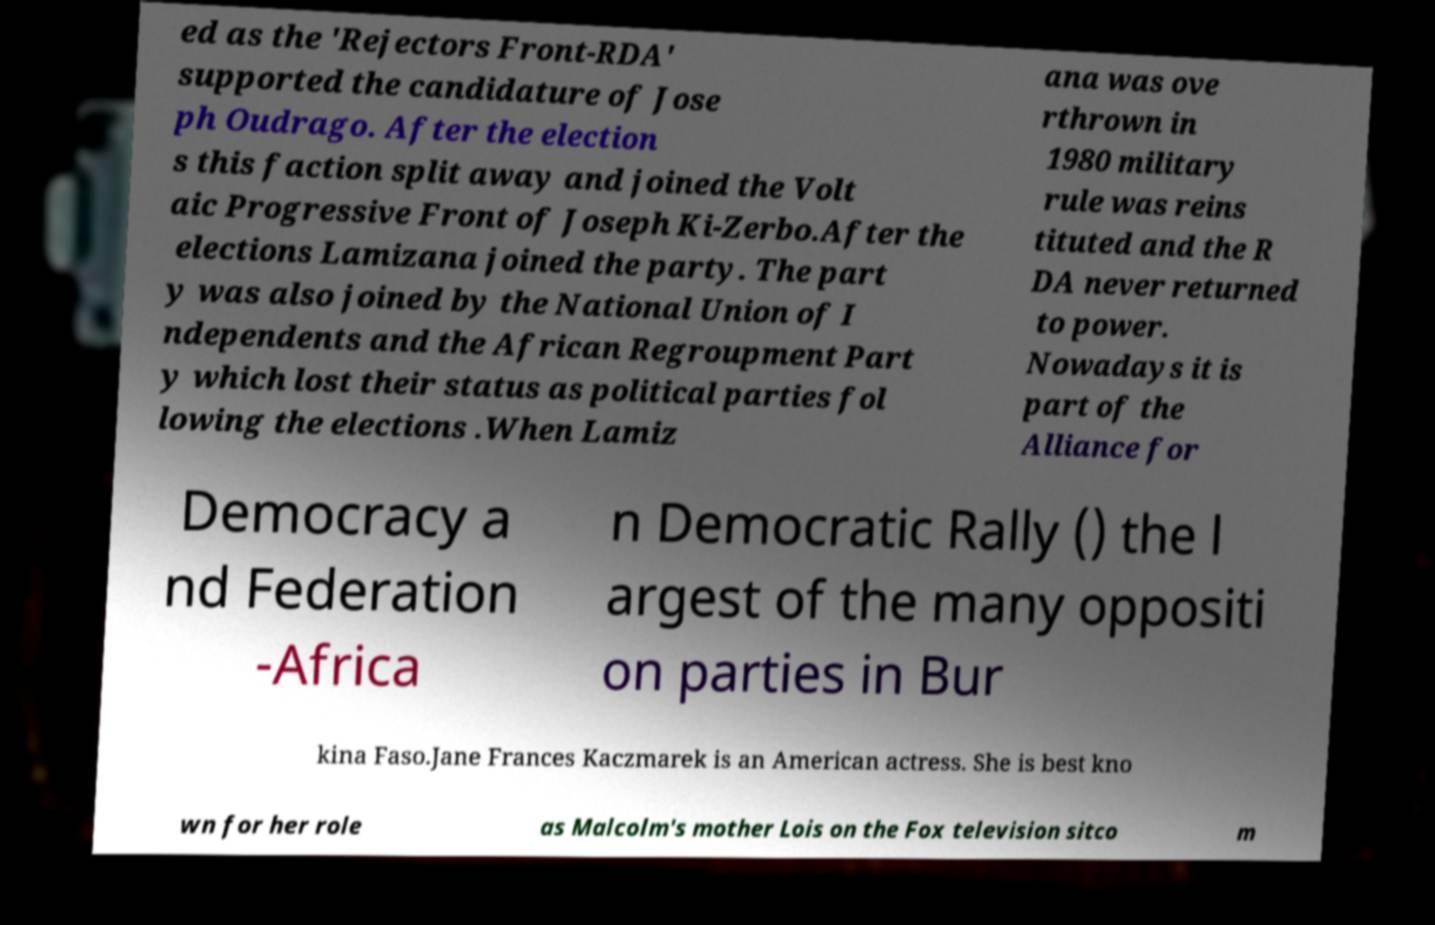There's text embedded in this image that I need extracted. Can you transcribe it verbatim? ed as the 'Rejectors Front-RDA' supported the candidature of Jose ph Oudrago. After the election s this faction split away and joined the Volt aic Progressive Front of Joseph Ki-Zerbo.After the elections Lamizana joined the party. The part y was also joined by the National Union of I ndependents and the African Regroupment Part y which lost their status as political parties fol lowing the elections .When Lamiz ana was ove rthrown in 1980 military rule was reins tituted and the R DA never returned to power. Nowadays it is part of the Alliance for Democracy a nd Federation -Africa n Democratic Rally () the l argest of the many oppositi on parties in Bur kina Faso.Jane Frances Kaczmarek is an American actress. She is best kno wn for her role as Malcolm's mother Lois on the Fox television sitco m 